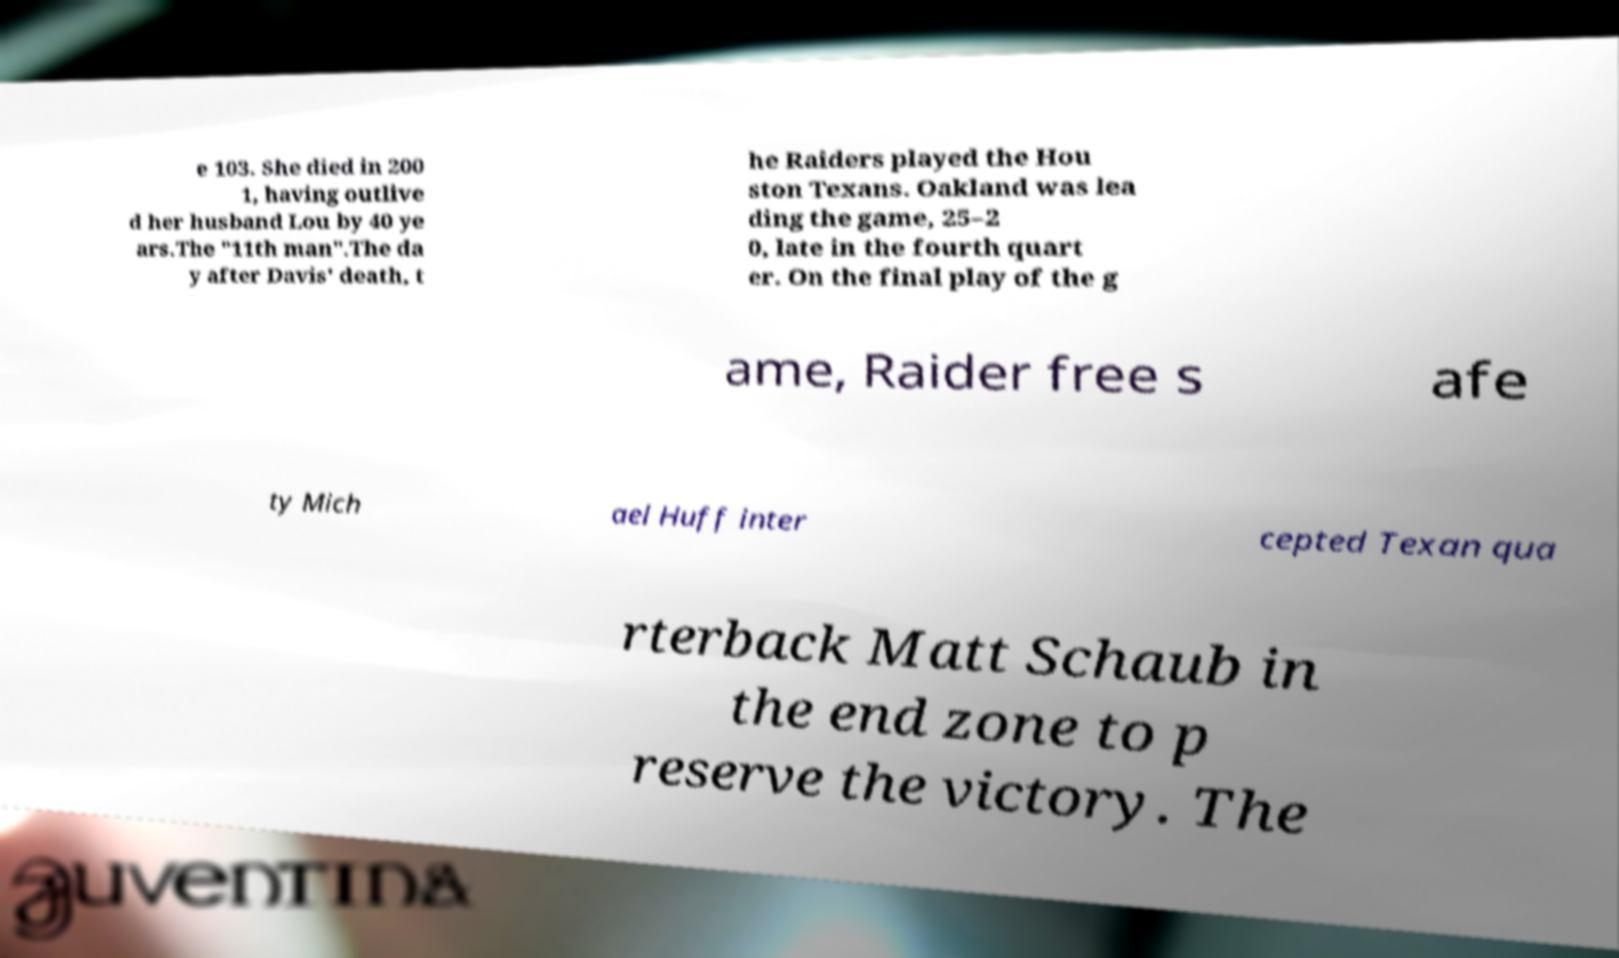Can you read and provide the text displayed in the image?This photo seems to have some interesting text. Can you extract and type it out for me? e 103. She died in 200 1, having outlive d her husband Lou by 40 ye ars.The "11th man".The da y after Davis' death, t he Raiders played the Hou ston Texans. Oakland was lea ding the game, 25–2 0, late in the fourth quart er. On the final play of the g ame, Raider free s afe ty Mich ael Huff inter cepted Texan qua rterback Matt Schaub in the end zone to p reserve the victory. The 